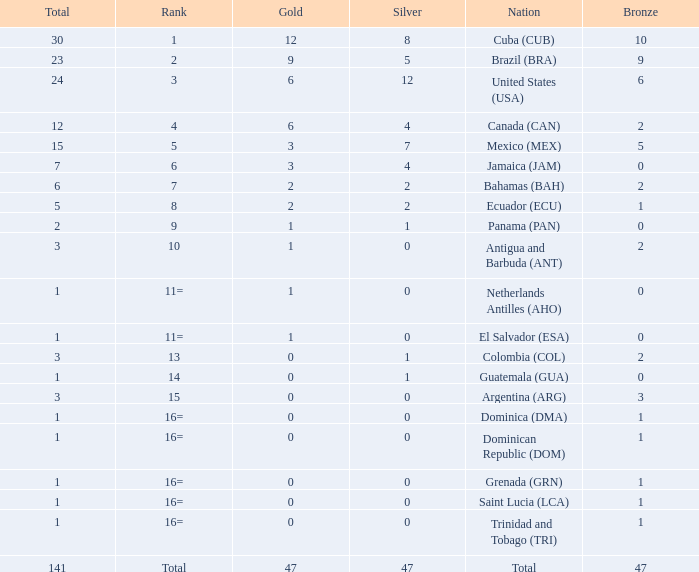What is the total gold with a total less than 1? None. 